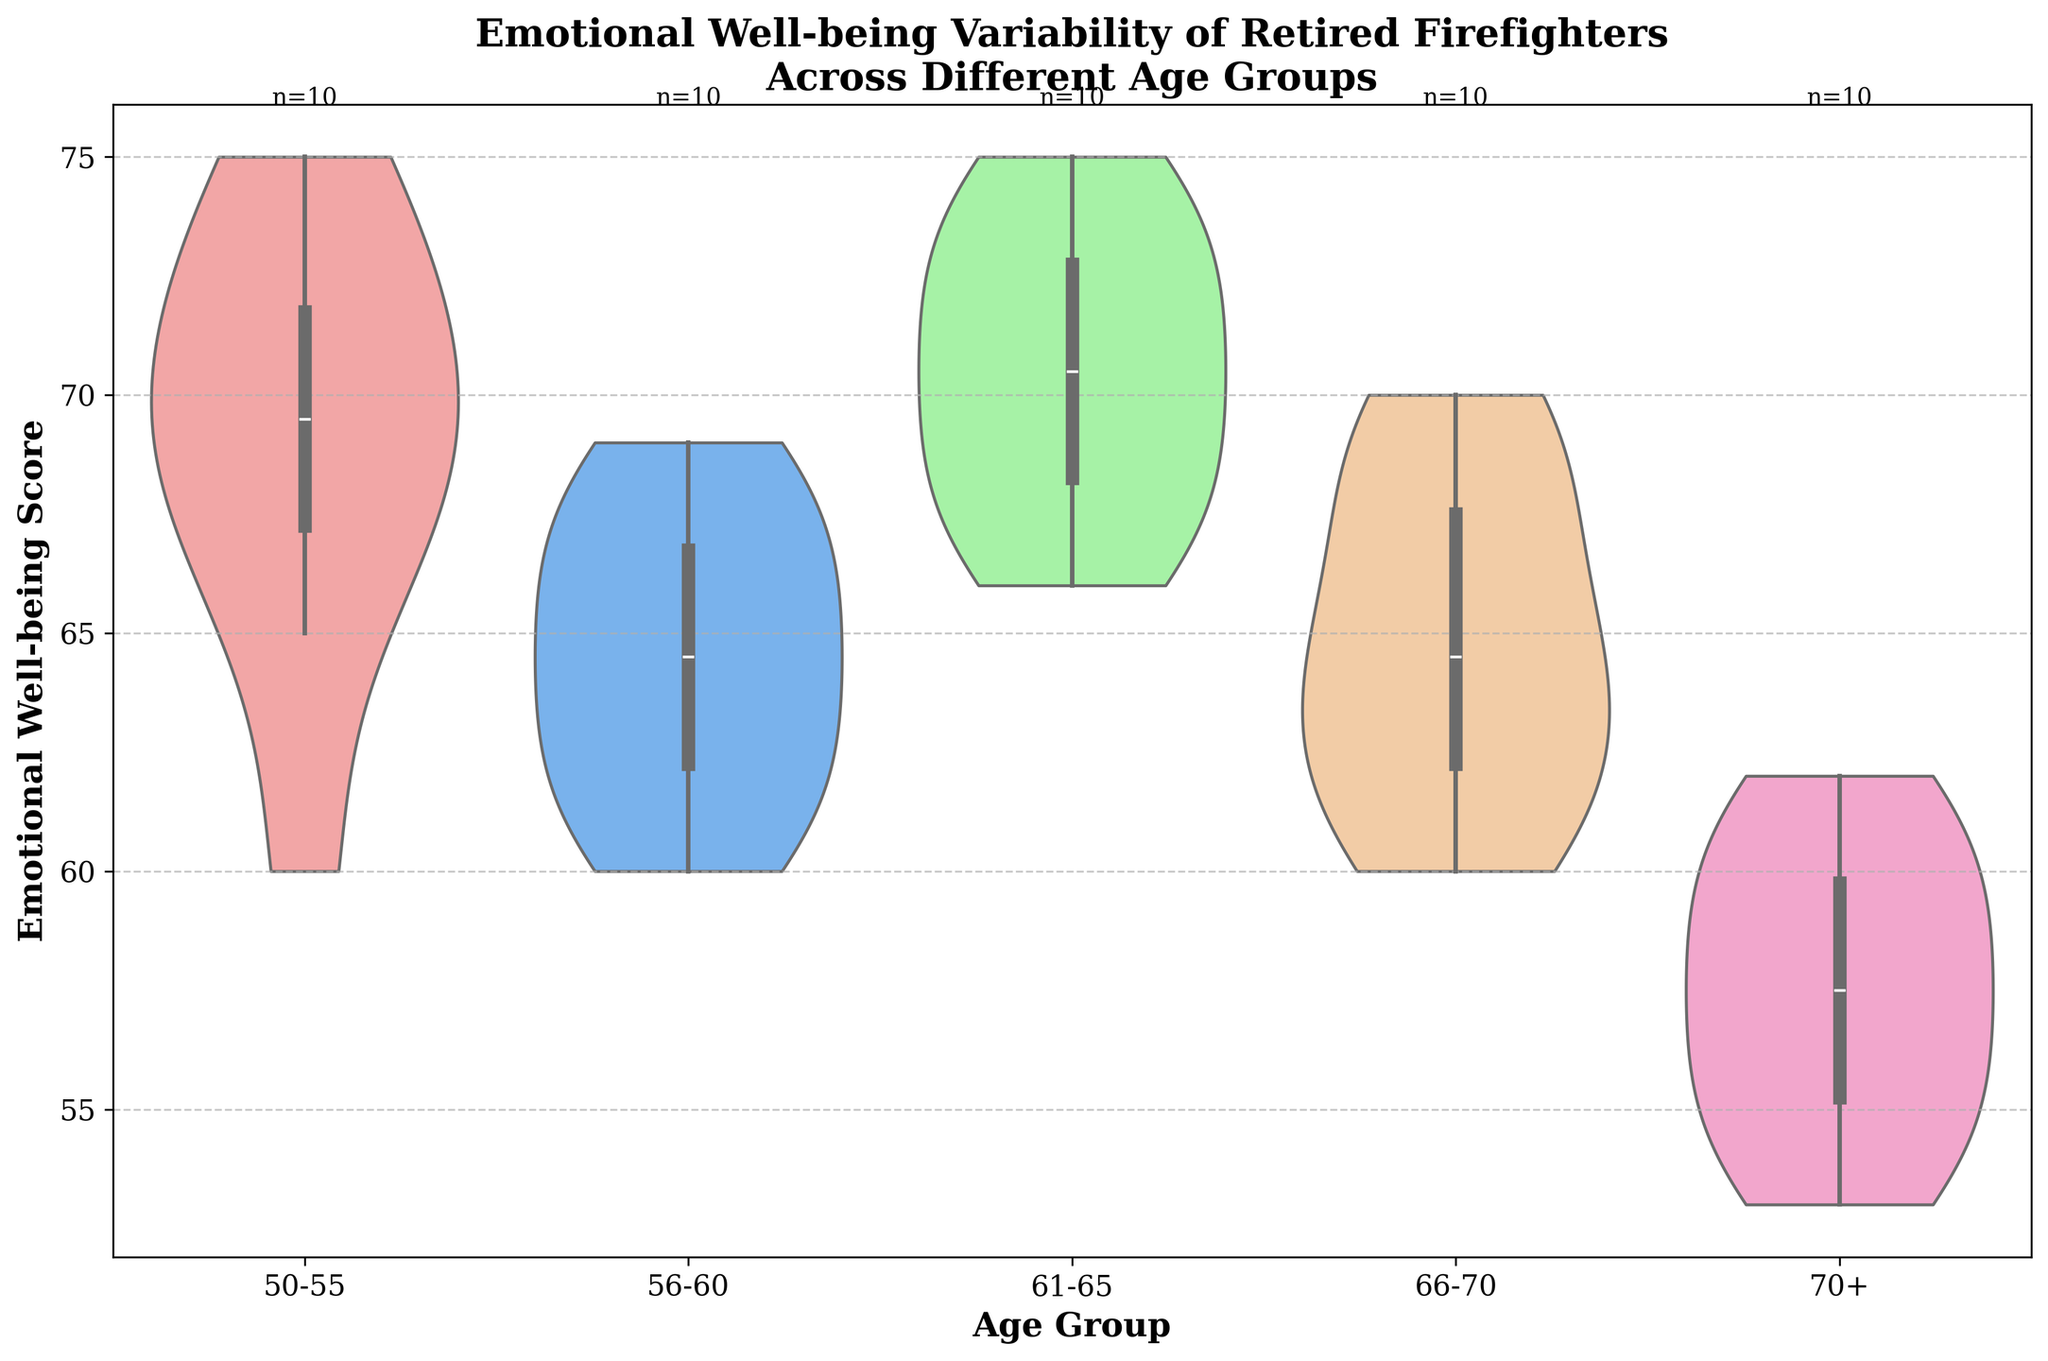which age group shows the widest variability in emotional well-being scores? The width of the violin plot reflects the variability in scores. The age group 61-65 has the widest distribution, indicating the most variability.
Answer: 61-65 Which age group has the highest median emotional well-being score? The inner box plot within the violin plot shows the median. The age group 61-65 has the highest median score as it is visually higher than the other groups.
Answer: 61-65 How does the emotional well-being of the 70+ age group compare to the 50-55 age group? By comparing the position and spread of the plots, the 70+ age group appears to have a lower median and narrower spread compared to the 50-55 age group, indicating lower and less variable scores.
Answer: Lower and less variable What is the approximate interquartile range (IQR) for the 56-60 age group? The IQR is the range between the first and third quartiles in the box plot. For the 56-60 group, this is approximately from 61 to 66. IQR is 66 - 61 = 5.
Answer: 5 Which age group appears to have the most balanced distribution of emotional well-being scores? A balanced distribution would have a symmetrical shape with even spread around the median. The 61-65 age group has a fairly symmetrical shape with the median in the center.
Answer: 61-65 Is there any age group with potential outliers in emotional well-being scores? Outliers would appear as points outside the central mass of the violin plot. The 70+ group has a couple of points far from the main distribution.
Answer: 70+ Which age group has the lowest maximum emotional well-being score? The top end of the violin plot indicates the maximum score. The 70+ age group has the lowest maximum score.
Answer: 70+ What is the most common score range for the 50-55 age group? The widest part of the violin plot indicates the most common score range. For the 50-55 age group, this range is approximately 68-74.
Answer: 68-74 How many data points are there for the 61-65 age group? The text annotation on top of the violin plot shows the count of data points. For 61-65, it is noted as n=10.
Answer: 10 Which age group shows an upward trend in emotional well-being scores as firefighters age from 50-55 to 61-65? By comparing the median values of the violin plots, the score increases from 50-55 to 61-65 age groups. The median scores live on a visual upward trend.
Answer: 50-55 to 61-65 